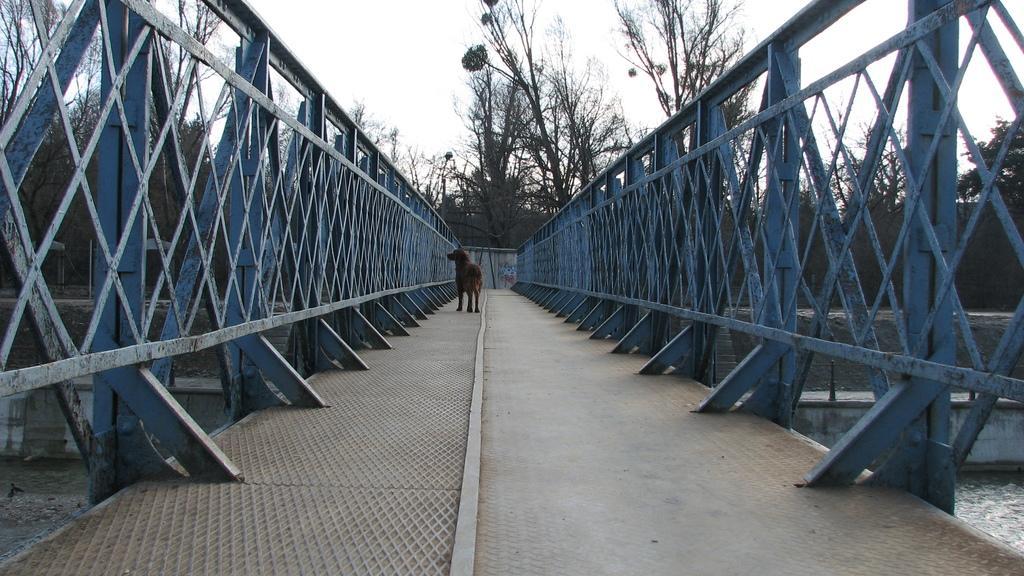How would you summarize this image in a sentence or two? In this image I can see a dog standing on a bridge. It has fence on the either sides. There is water at the bottom. There are trees at the back and there is sky at the top. 